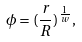Convert formula to latex. <formula><loc_0><loc_0><loc_500><loc_500>\phi = ( \frac { r } { R } ) ^ { \frac { 1 } { w } } ,</formula> 